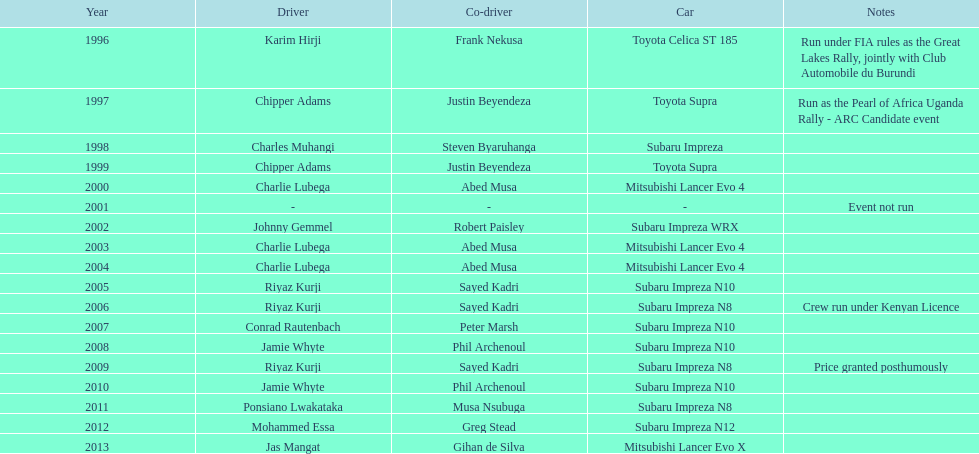In which single year was the event not held? 2001. 